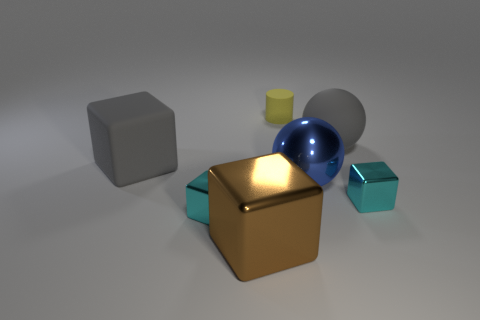Subtract all gray blocks. How many blocks are left? 3 Subtract all cyan balls. How many cyan blocks are left? 2 Subtract 2 blocks. How many blocks are left? 2 Subtract all brown blocks. How many blocks are left? 3 Add 2 big spheres. How many objects exist? 9 Subtract all blocks. How many objects are left? 3 Subtract all blue cubes. Subtract all yellow balls. How many cubes are left? 4 Subtract all big purple blocks. Subtract all large blue metallic things. How many objects are left? 6 Add 3 rubber cubes. How many rubber cubes are left? 4 Add 2 big gray matte balls. How many big gray matte balls exist? 3 